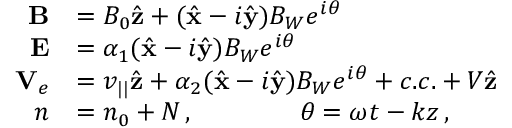<formula> <loc_0><loc_0><loc_500><loc_500>\begin{array} { r l } { B } & { = B _ { 0 } \hat { z } + ( \hat { x } - i \hat { y } ) B _ { W } e ^ { i \theta } } \\ { E } & { = \alpha _ { 1 } ( \hat { x } - i \hat { y } ) B _ { W } e ^ { i \theta } } \\ { { V } _ { e } } & { = v _ { | | } \hat { z } + \alpha _ { 2 } ( \hat { x } - i \hat { y } ) B _ { W } e ^ { i \theta } + c . c . + V \hat { z } } \\ { n } & { = n _ { 0 } + N \, , \quad \theta = \omega t - k z \, , } \end{array}</formula> 